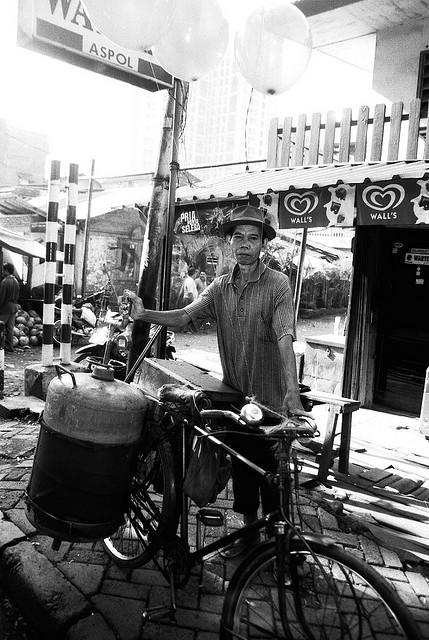What is the shape of the Wall's logo? heart 